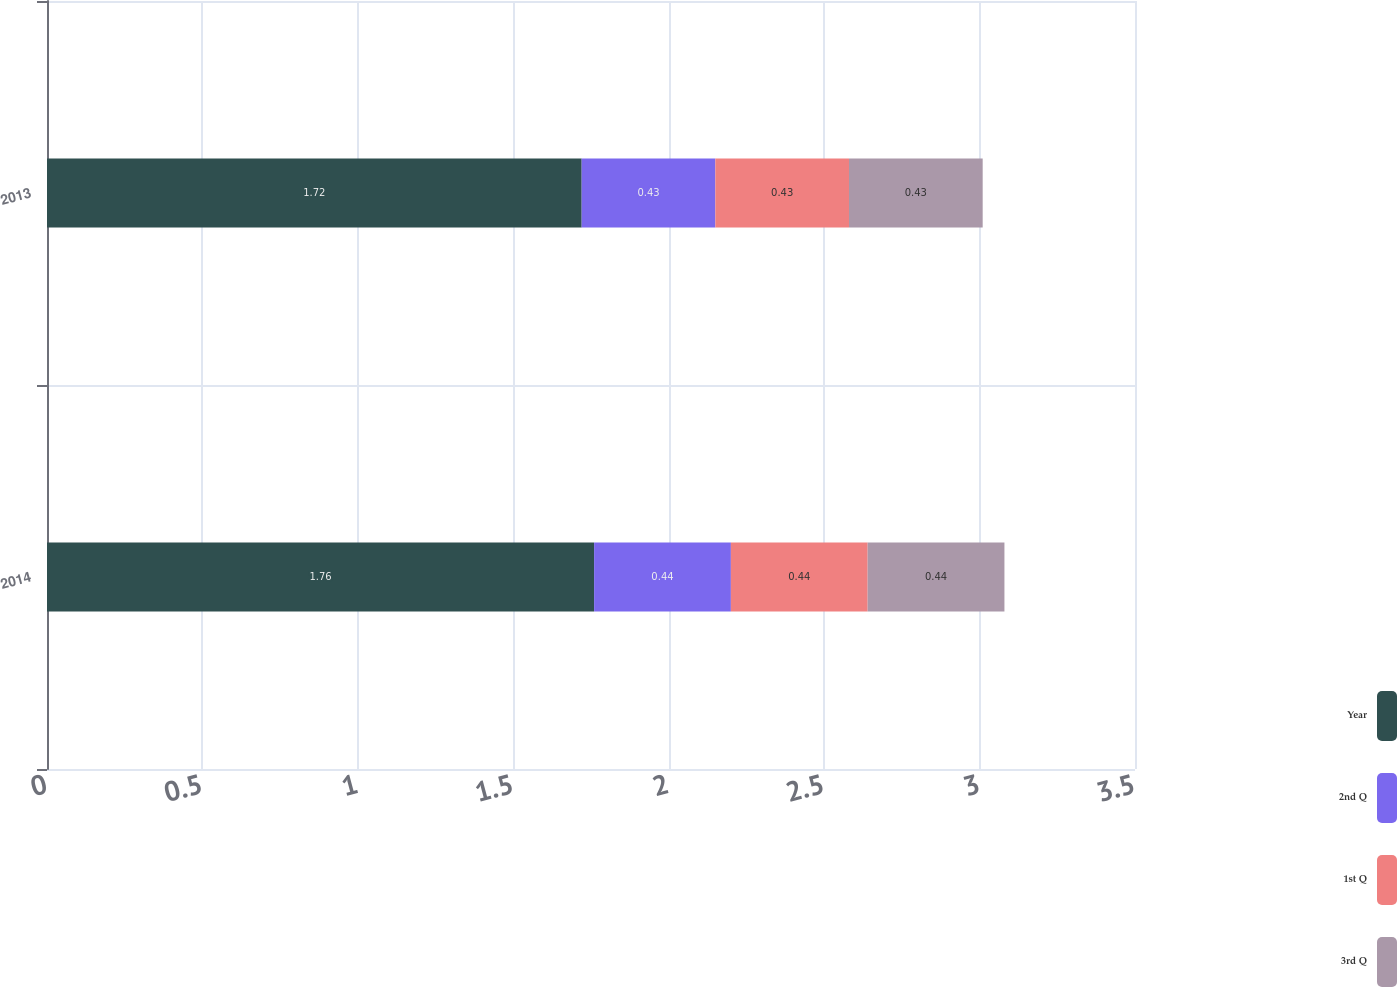<chart> <loc_0><loc_0><loc_500><loc_500><stacked_bar_chart><ecel><fcel>2014<fcel>2013<nl><fcel>Year<fcel>1.76<fcel>1.72<nl><fcel>2nd Q<fcel>0.44<fcel>0.43<nl><fcel>1st Q<fcel>0.44<fcel>0.43<nl><fcel>3rd Q<fcel>0.44<fcel>0.43<nl></chart> 